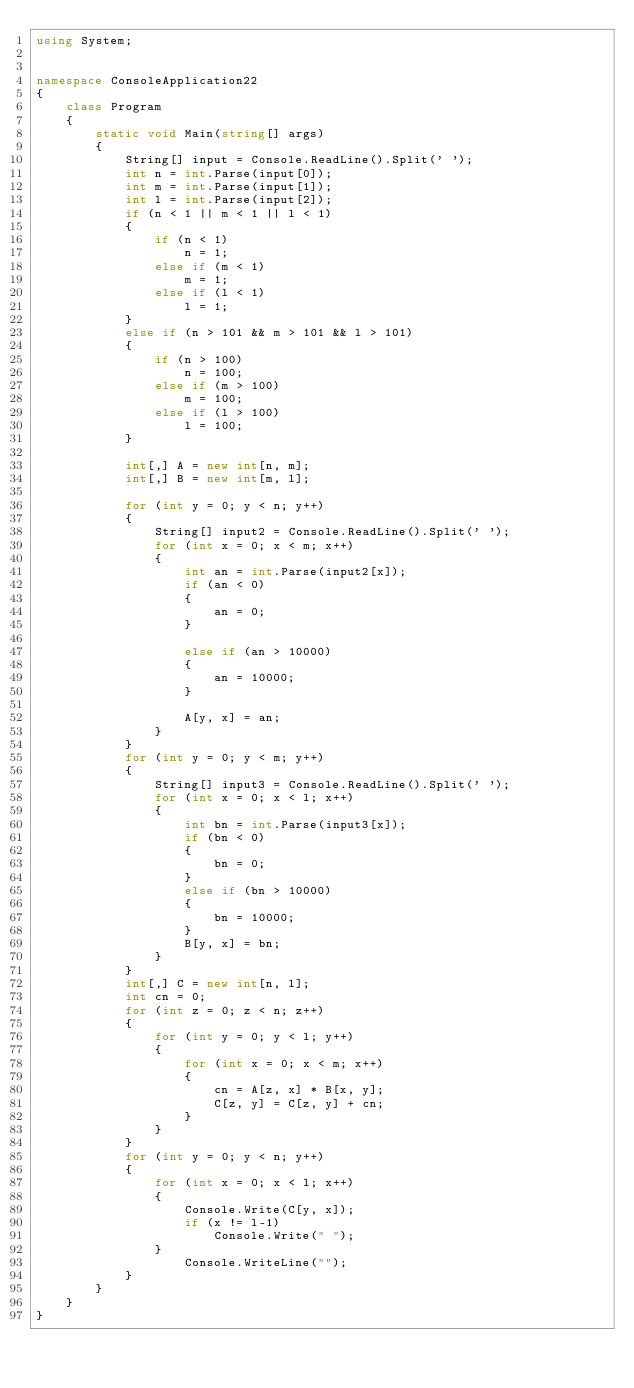Convert code to text. <code><loc_0><loc_0><loc_500><loc_500><_C#_>using System;


namespace ConsoleApplication22
{
    class Program
    {
        static void Main(string[] args)
        {
            String[] input = Console.ReadLine().Split(' ');
            int n = int.Parse(input[0]);
            int m = int.Parse(input[1]);
            int l = int.Parse(input[2]);
            if (n < 1 || m < 1 || l < 1)
            {
                if (n < 1)
                    n = 1;
                else if (m < 1)
                    m = 1;
                else if (l < 1)
                    l = 1;
            }
            else if (n > 101 && m > 101 && l > 101)
            {
                if (n > 100)
                    n = 100;
                else if (m > 100)
                    m = 100;
                else if (l > 100)
                    l = 100;
            }

            int[,] A = new int[n, m];
            int[,] B = new int[m, l];

            for (int y = 0; y < n; y++)
            {
                String[] input2 = Console.ReadLine().Split(' ');
                for (int x = 0; x < m; x++)
                {
                    int an = int.Parse(input2[x]);
                    if (an < 0)
                    {
                        an = 0;
                    }
                    
                    else if (an > 10000)
                    {
                        an = 10000;
                    }

                    A[y, x] = an;
                }
            }
            for (int y = 0; y < m; y++)
            {
                String[] input3 = Console.ReadLine().Split(' ');
                for (int x = 0; x < l; x++)
                {
                    int bn = int.Parse(input3[x]);
                    if (bn < 0)
                    {
                        bn = 0;
                    }
                    else if (bn > 10000)
                    {
                        bn = 10000;
                    }
                    B[y, x] = bn;
                }
            }
            int[,] C = new int[n, l];
            int cn = 0;
            for (int z = 0; z < n; z++)
            {
                for (int y = 0; y < l; y++)
                {
                    for (int x = 0; x < m; x++)
                    {
                        cn = A[z, x] * B[x, y];
                        C[z, y] = C[z, y] + cn;
                    }
                }
            }
            for (int y = 0; y < n; y++)
            {
                for (int x = 0; x < l; x++)
                {
                    Console.Write(C[y, x]);
                    if (x != l-1)
                        Console.Write(" ");
                }
                    Console.WriteLine("");
            }
        }
    }
}</code> 